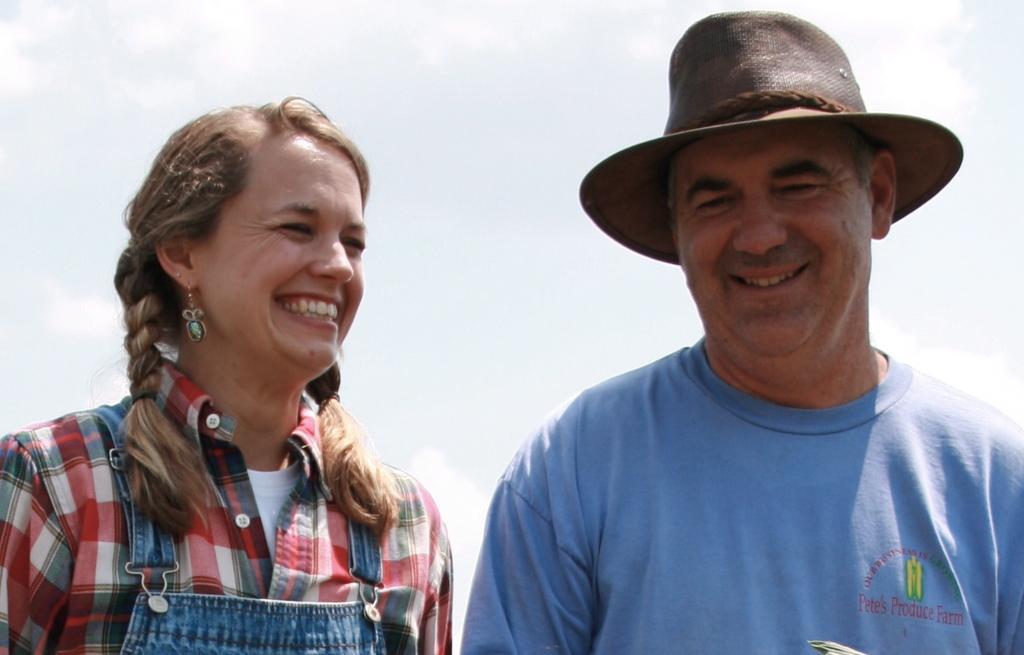How would you summarize this image in a sentence or two? This image is taken outdoors. At the top of the image there is a sky with clouds. In the middle of the image there is a man and a woman with smiling faces. 